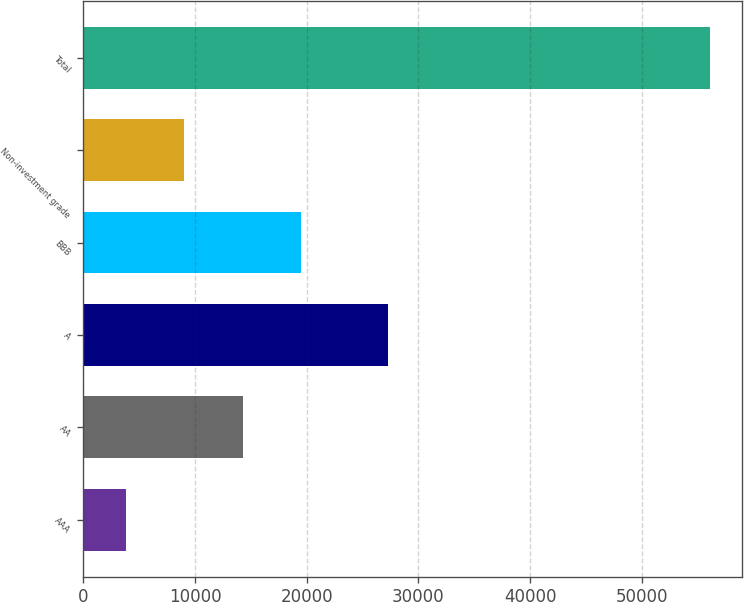Convert chart to OTSL. <chart><loc_0><loc_0><loc_500><loc_500><bar_chart><fcel>AAA<fcel>AA<fcel>A<fcel>BBB<fcel>Non-investment grade<fcel>Total<nl><fcel>3780<fcel>14247.4<fcel>27277<fcel>19481.1<fcel>9013.7<fcel>56117<nl></chart> 